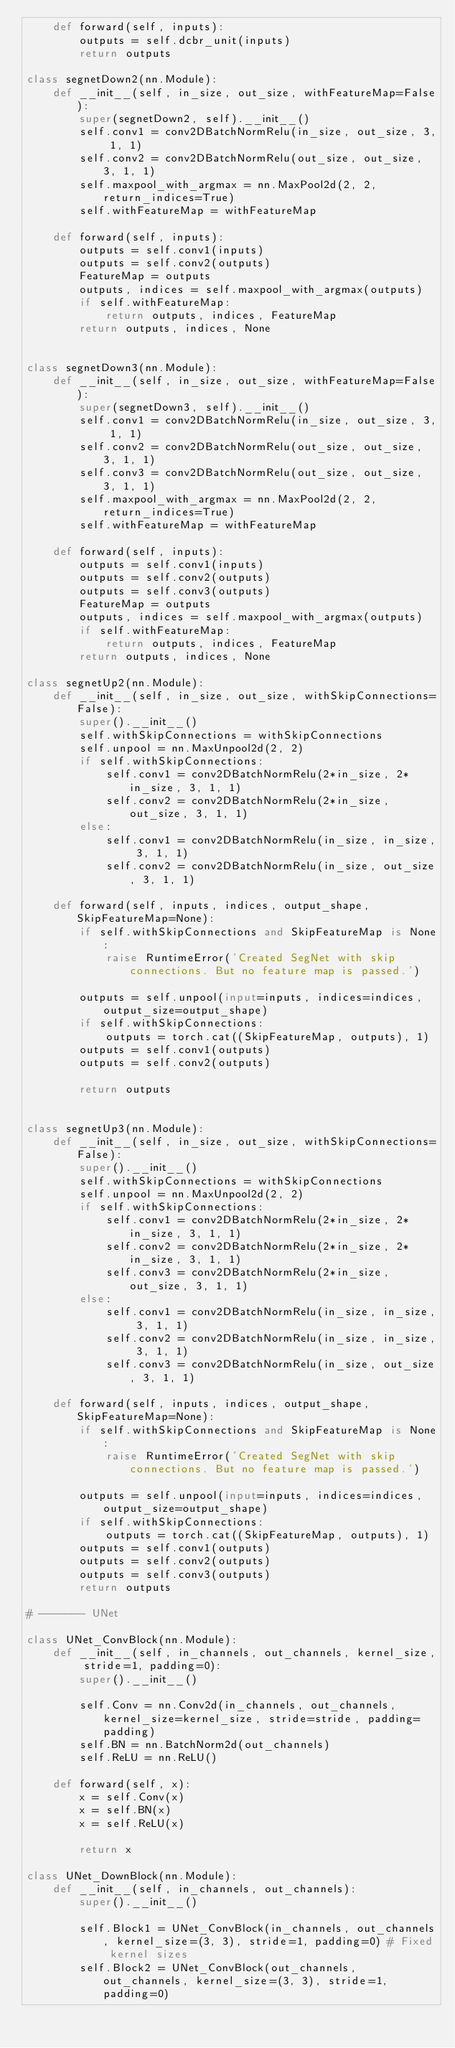Convert code to text. <code><loc_0><loc_0><loc_500><loc_500><_Python_>    def forward(self, inputs):
        outputs = self.dcbr_unit(inputs)
        return outputs

class segnetDown2(nn.Module):
    def __init__(self, in_size, out_size, withFeatureMap=False):
        super(segnetDown2, self).__init__()
        self.conv1 = conv2DBatchNormRelu(in_size, out_size, 3, 1, 1)
        self.conv2 = conv2DBatchNormRelu(out_size, out_size, 3, 1, 1)
        self.maxpool_with_argmax = nn.MaxPool2d(2, 2, return_indices=True)
        self.withFeatureMap = withFeatureMap

    def forward(self, inputs):
        outputs = self.conv1(inputs)
        outputs = self.conv2(outputs)
        FeatureMap = outputs
        outputs, indices = self.maxpool_with_argmax(outputs)
        if self.withFeatureMap:
            return outputs, indices, FeatureMap
        return outputs, indices, None


class segnetDown3(nn.Module):
    def __init__(self, in_size, out_size, withFeatureMap=False):
        super(segnetDown3, self).__init__()
        self.conv1 = conv2DBatchNormRelu(in_size, out_size, 3, 1, 1)
        self.conv2 = conv2DBatchNormRelu(out_size, out_size, 3, 1, 1)
        self.conv3 = conv2DBatchNormRelu(out_size, out_size, 3, 1, 1)
        self.maxpool_with_argmax = nn.MaxPool2d(2, 2, return_indices=True)
        self.withFeatureMap = withFeatureMap

    def forward(self, inputs):
        outputs = self.conv1(inputs)
        outputs = self.conv2(outputs)
        outputs = self.conv3(outputs)
        FeatureMap = outputs
        outputs, indices = self.maxpool_with_argmax(outputs)
        if self.withFeatureMap:
            return outputs, indices, FeatureMap
        return outputs, indices, None

class segnetUp2(nn.Module):
    def __init__(self, in_size, out_size, withSkipConnections=False):
        super().__init__()
        self.withSkipConnections = withSkipConnections
        self.unpool = nn.MaxUnpool2d(2, 2)
        if self.withSkipConnections:
            self.conv1 = conv2DBatchNormRelu(2*in_size, 2*in_size, 3, 1, 1)
            self.conv2 = conv2DBatchNormRelu(2*in_size, out_size, 3, 1, 1)
        else:
            self.conv1 = conv2DBatchNormRelu(in_size, in_size, 3, 1, 1)
            self.conv2 = conv2DBatchNormRelu(in_size, out_size, 3, 1, 1)

    def forward(self, inputs, indices, output_shape, SkipFeatureMap=None):
        if self.withSkipConnections and SkipFeatureMap is None:
            raise RuntimeError('Created SegNet with skip connections. But no feature map is passed.')

        outputs = self.unpool(input=inputs, indices=indices, output_size=output_shape)
        if self.withSkipConnections:
            outputs = torch.cat((SkipFeatureMap, outputs), 1)
        outputs = self.conv1(outputs)
        outputs = self.conv2(outputs)

        return outputs


class segnetUp3(nn.Module):
    def __init__(self, in_size, out_size, withSkipConnections=False):
        super().__init__()
        self.withSkipConnections = withSkipConnections
        self.unpool = nn.MaxUnpool2d(2, 2)
        if self.withSkipConnections:
            self.conv1 = conv2DBatchNormRelu(2*in_size, 2*in_size, 3, 1, 1)
            self.conv2 = conv2DBatchNormRelu(2*in_size, 2*in_size, 3, 1, 1)
            self.conv3 = conv2DBatchNormRelu(2*in_size, out_size, 3, 1, 1)
        else:
            self.conv1 = conv2DBatchNormRelu(in_size, in_size, 3, 1, 1)
            self.conv2 = conv2DBatchNormRelu(in_size, in_size, 3, 1, 1)
            self.conv3 = conv2DBatchNormRelu(in_size, out_size, 3, 1, 1)

    def forward(self, inputs, indices, output_shape, SkipFeatureMap=None):
        if self.withSkipConnections and SkipFeatureMap is None:
            raise RuntimeError('Created SegNet with skip connections. But no feature map is passed.')

        outputs = self.unpool(input=inputs, indices=indices, output_size=output_shape)
        if self.withSkipConnections:
            outputs = torch.cat((SkipFeatureMap, outputs), 1)
        outputs = self.conv1(outputs)
        outputs = self.conv2(outputs)
        outputs = self.conv3(outputs)
        return outputs

# ------- UNet

class UNet_ConvBlock(nn.Module):
    def __init__(self, in_channels, out_channels, kernel_size, stride=1, padding=0):
        super().__init__()

        self.Conv = nn.Conv2d(in_channels, out_channels, kernel_size=kernel_size, stride=stride, padding=padding)
        self.BN = nn.BatchNorm2d(out_channels)
        self.ReLU = nn.ReLU()

    def forward(self, x):
        x = self.Conv(x)
        x = self.BN(x)
        x = self.ReLU(x)

        return x

class UNet_DownBlock(nn.Module):
    def __init__(self, in_channels, out_channels):
        super().__init__()

        self.Block1 = UNet_ConvBlock(in_channels, out_channels, kernel_size=(3, 3), stride=1, padding=0) # Fixed kernel sizes
        self.Block2 = UNet_ConvBlock(out_channels, out_channels, kernel_size=(3, 3), stride=1, padding=0)</code> 